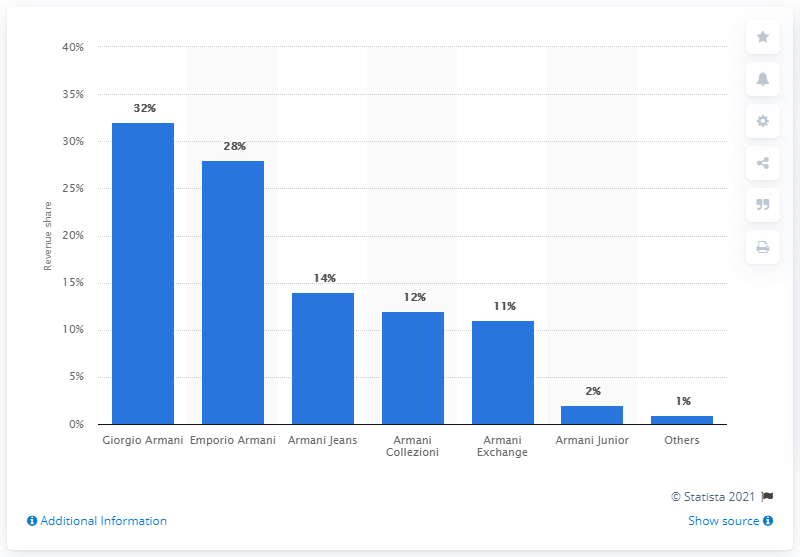Point out several critical features in this image. In 2009, Armani Junior, a brand within the Armani Group, accounted for two percent of the group's total revenue. 